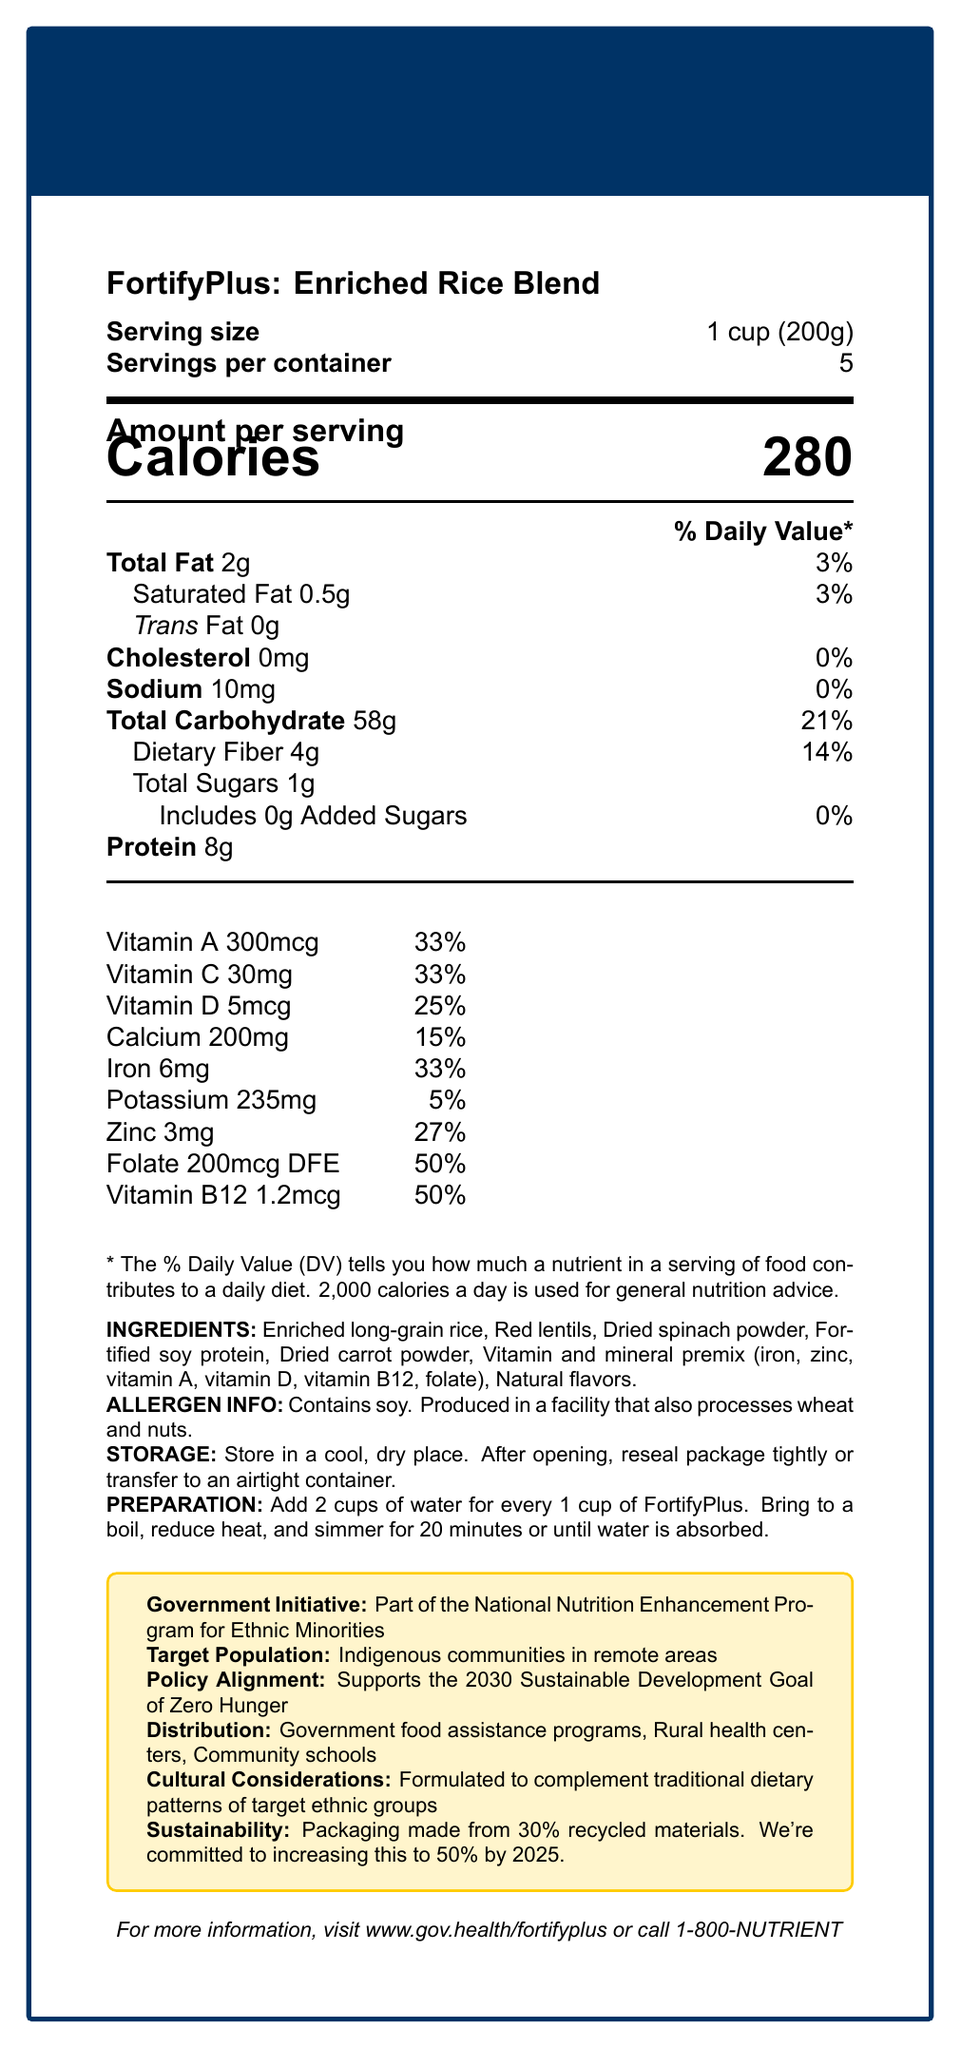What is the serving size of FortifyPlus: Enriched Rice Blend? The serving size is clearly listed as "1 cup (200g)" in the document under "Serving size."
Answer: 1 cup (200g) How many calories are in one serving? The calorie count is prominently displayed as "Calories 280" in the "Amount per serving" section.
Answer: 280 What percentage of the Daily Value of Vitamin A does one serving of FortifyPlus provide? The document states "Vitamin A 300mcg" which constitutes "33%" of the Daily Value.
Answer: 33% List three vitamins and their daily values provided by FortifyPlus. The vitamins and their daily values are listed in the document: Vitamin A 33%, Vitamin C 33%, and Vitamin D 25%.
Answer: Vitamin A 33%, Vitamin C 33%, Vitamin D 25% Does the product contain added sugars? The document mentions "Includes 0g Added Sugars" under the total sugars section, indicating that it contains no added sugars.
Answer: No What are the first three ingredients in FortifyPlus? The ingredients listed first are "Enriched long-grain rice, Red lentils, Dried spinach powder."
Answer: Enriched long-grain rice, Red lentils, Dried spinach powder Which of the following is a correct serving size option? A. 1 cup (150g) B. 1 cup (200g) C. 1 cup (250g) The document states that the serving size is "1 cup (200g)."
Answer: B. 1 cup (200g) What is the amount of protein per serving in FortifyPlus? A. 7g B. 8g C. 9g D. 10g The document specifies that the protein content per serving is "8g."
Answer: B. 8g Is this product soy-free? The allergen information states "Contains soy."
Answer: No Summarize the key points of the Nutrition Facts document for FortifyPlus. This summary provides a comprehensive overview by combining various sections such as nutrition, target audience, government initiative, cultural considerations, and sustainability commitments.
Answer: The FortifyPlus: Enriched Rice Blend is a nutrient-dense food designed to address malnutrition in specific ethnic minority groups. It offers significant amounts of essential nutrients per serving, including high percentages of daily values of Vitamin A, Vitamin C, and iron. The product contains soy and may be allergenic to some. It is part of a government initiative and aligns with sustainable development goals, being specifically formulated to complement traditional diets of target ethnic groups, and distributed through various government and community channels. Does FortifyPlus support any specific sustainable development goals? The document explicitly mentions that the product supports "the 2030 Sustainable Development Goal of Zero Hunger."
Answer: Yes, it supports the 2030 Sustainable Development Goal of Zero Hunger. Is the exact composition of the vitamin and mineral premix disclosed? The document lists that the premix includes iron, zinc, vitamin A, vitamin D, vitamin B12, and folate, but does not provide the exact composition or amounts of each component in the premix.
Answer: No Is FortifyPlus suitable for people with nut allergies? The document notes that the product is "Produced in a facility that also processes wheat and nuts," making it potentially unsafe for people with nut allergies.
Answer: Not recommended How should FortifyPlus be stored? The storage instructions in the document specify to "Store in a cool, dry place" and to "reseal package tightly or transfer to an airtight container" after opening.
Answer: Store in a cool, dry place. After opening, reseal package tightly or transfer to an airtight container. 